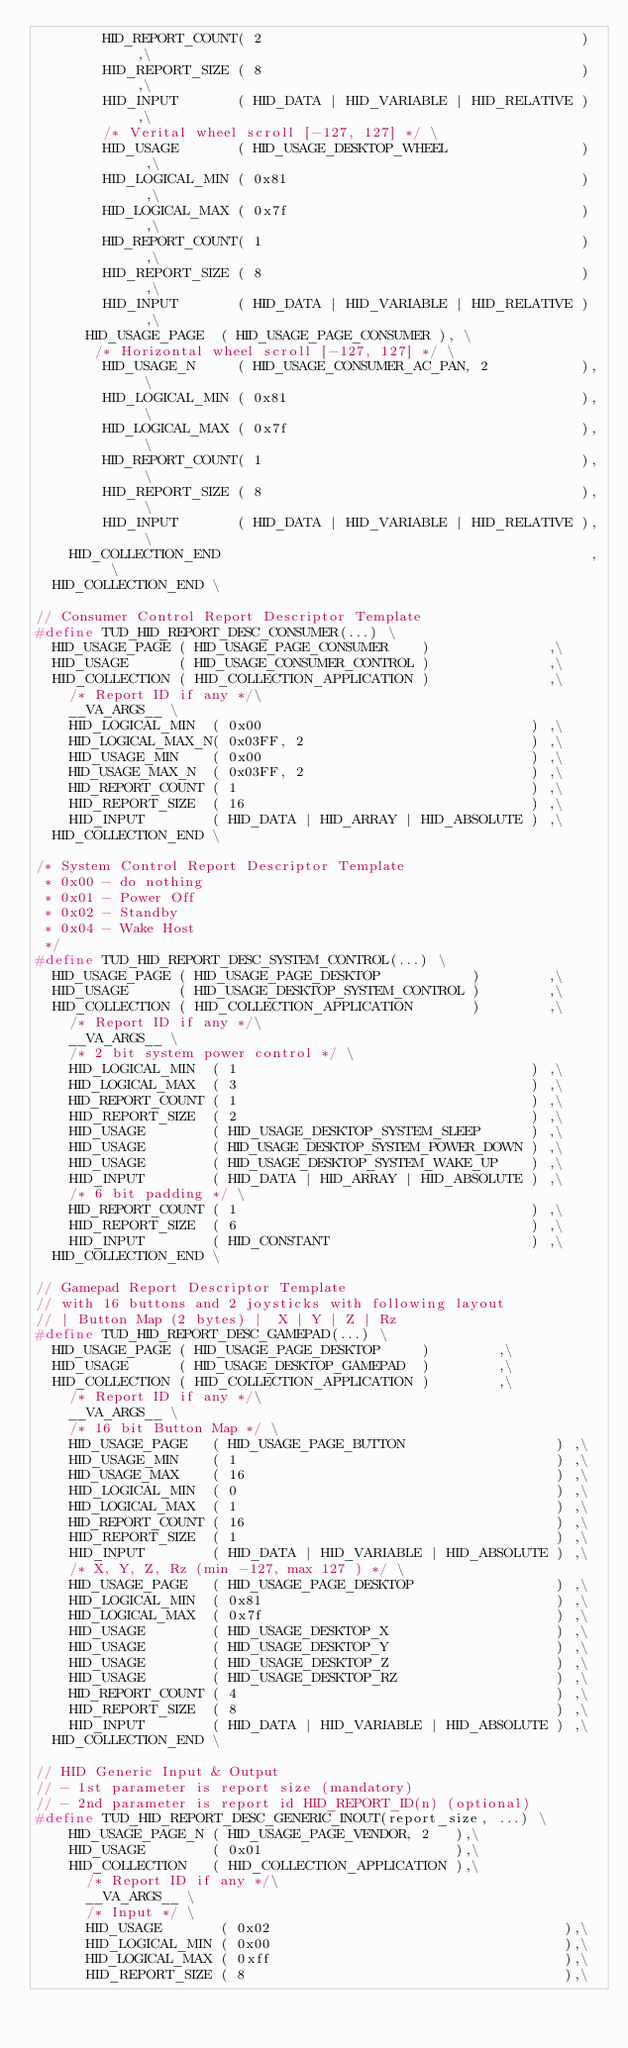Convert code to text. <code><loc_0><loc_0><loc_500><loc_500><_C_>        HID_REPORT_COUNT( 2                                      ) ,\
        HID_REPORT_SIZE ( 8                                      ) ,\
        HID_INPUT       ( HID_DATA | HID_VARIABLE | HID_RELATIVE ) ,\
        /* Verital wheel scroll [-127, 127] */ \
        HID_USAGE       ( HID_USAGE_DESKTOP_WHEEL                )  ,\
        HID_LOGICAL_MIN ( 0x81                                   )  ,\
        HID_LOGICAL_MAX ( 0x7f                                   )  ,\
        HID_REPORT_COUNT( 1                                      )  ,\
        HID_REPORT_SIZE ( 8                                      )  ,\
        HID_INPUT       ( HID_DATA | HID_VARIABLE | HID_RELATIVE )  ,\
      HID_USAGE_PAGE  ( HID_USAGE_PAGE_CONSUMER ), \
       /* Horizontal wheel scroll [-127, 127] */ \
        HID_USAGE_N     ( HID_USAGE_CONSUMER_AC_PAN, 2           ), \
        HID_LOGICAL_MIN ( 0x81                                   ), \
        HID_LOGICAL_MAX ( 0x7f                                   ), \
        HID_REPORT_COUNT( 1                                      ), \
        HID_REPORT_SIZE ( 8                                      ), \
        HID_INPUT       ( HID_DATA | HID_VARIABLE | HID_RELATIVE ), \
    HID_COLLECTION_END                                            , \
  HID_COLLECTION_END \

// Consumer Control Report Descriptor Template
#define TUD_HID_REPORT_DESC_CONSUMER(...) \
  HID_USAGE_PAGE ( HID_USAGE_PAGE_CONSUMER    )              ,\
  HID_USAGE      ( HID_USAGE_CONSUMER_CONTROL )              ,\
  HID_COLLECTION ( HID_COLLECTION_APPLICATION )              ,\
    /* Report ID if any */\
    __VA_ARGS__ \
    HID_LOGICAL_MIN  ( 0x00                                ) ,\
    HID_LOGICAL_MAX_N( 0x03FF, 2                           ) ,\
    HID_USAGE_MIN    ( 0x00                                ) ,\
    HID_USAGE_MAX_N  ( 0x03FF, 2                           ) ,\
    HID_REPORT_COUNT ( 1                                   ) ,\
    HID_REPORT_SIZE  ( 16                                  ) ,\
    HID_INPUT        ( HID_DATA | HID_ARRAY | HID_ABSOLUTE ) ,\
  HID_COLLECTION_END \

/* System Control Report Descriptor Template
 * 0x00 - do nothing
 * 0x01 - Power Off
 * 0x02 - Standby
 * 0x04 - Wake Host
 */
#define TUD_HID_REPORT_DESC_SYSTEM_CONTROL(...) \
  HID_USAGE_PAGE ( HID_USAGE_PAGE_DESKTOP           )        ,\
  HID_USAGE      ( HID_USAGE_DESKTOP_SYSTEM_CONTROL )        ,\
  HID_COLLECTION ( HID_COLLECTION_APPLICATION       )        ,\
    /* Report ID if any */\
    __VA_ARGS__ \
    /* 2 bit system power control */ \
    HID_LOGICAL_MIN  ( 1                                   ) ,\
    HID_LOGICAL_MAX  ( 3                                   ) ,\
    HID_REPORT_COUNT ( 1                                   ) ,\
    HID_REPORT_SIZE  ( 2                                   ) ,\
    HID_USAGE        ( HID_USAGE_DESKTOP_SYSTEM_SLEEP      ) ,\
    HID_USAGE        ( HID_USAGE_DESKTOP_SYSTEM_POWER_DOWN ) ,\
    HID_USAGE        ( HID_USAGE_DESKTOP_SYSTEM_WAKE_UP    ) ,\
    HID_INPUT        ( HID_DATA | HID_ARRAY | HID_ABSOLUTE ) ,\
    /* 6 bit padding */ \
    HID_REPORT_COUNT ( 1                                   ) ,\
    HID_REPORT_SIZE  ( 6                                   ) ,\
    HID_INPUT        ( HID_CONSTANT                        ) ,\
  HID_COLLECTION_END \

// Gamepad Report Descriptor Template
// with 16 buttons and 2 joysticks with following layout
// | Button Map (2 bytes) |  X | Y | Z | Rz
#define TUD_HID_REPORT_DESC_GAMEPAD(...) \
  HID_USAGE_PAGE ( HID_USAGE_PAGE_DESKTOP     )        ,\
  HID_USAGE      ( HID_USAGE_DESKTOP_GAMEPAD  )        ,\
  HID_COLLECTION ( HID_COLLECTION_APPLICATION )        ,\
    /* Report ID if any */\
    __VA_ARGS__ \
    /* 16 bit Button Map */ \
    HID_USAGE_PAGE   ( HID_USAGE_PAGE_BUTTON                  ) ,\
    HID_USAGE_MIN    ( 1                                      ) ,\
    HID_USAGE_MAX    ( 16                                     ) ,\
    HID_LOGICAL_MIN  ( 0                                      ) ,\
    HID_LOGICAL_MAX  ( 1                                      ) ,\
    HID_REPORT_COUNT ( 16                                     ) ,\
    HID_REPORT_SIZE  ( 1                                      ) ,\
    HID_INPUT        ( HID_DATA | HID_VARIABLE | HID_ABSOLUTE ) ,\
    /* X, Y, Z, Rz (min -127, max 127 ) */ \
    HID_USAGE_PAGE   ( HID_USAGE_PAGE_DESKTOP                 ) ,\
    HID_LOGICAL_MIN  ( 0x81                                   ) ,\
    HID_LOGICAL_MAX  ( 0x7f                                   ) ,\
    HID_USAGE        ( HID_USAGE_DESKTOP_X                    ) ,\
    HID_USAGE        ( HID_USAGE_DESKTOP_Y                    ) ,\
    HID_USAGE        ( HID_USAGE_DESKTOP_Z                    ) ,\
    HID_USAGE        ( HID_USAGE_DESKTOP_RZ                   ) ,\
    HID_REPORT_COUNT ( 4                                      ) ,\
    HID_REPORT_SIZE  ( 8                                      ) ,\
    HID_INPUT        ( HID_DATA | HID_VARIABLE | HID_ABSOLUTE ) ,\
  HID_COLLECTION_END \

// HID Generic Input & Output
// - 1st parameter is report size (mandatory)
// - 2nd parameter is report id HID_REPORT_ID(n) (optional)
#define TUD_HID_REPORT_DESC_GENERIC_INOUT(report_size, ...) \
    HID_USAGE_PAGE_N ( HID_USAGE_PAGE_VENDOR, 2   ),\
    HID_USAGE        ( 0x01                       ),\
    HID_COLLECTION   ( HID_COLLECTION_APPLICATION ),\
      /* Report ID if any */\
      __VA_ARGS__ \
      /* Input */ \
      HID_USAGE       ( 0x02                                   ),\
      HID_LOGICAL_MIN ( 0x00                                   ),\
      HID_LOGICAL_MAX ( 0xff                                   ),\
      HID_REPORT_SIZE ( 8                                      ),\</code> 